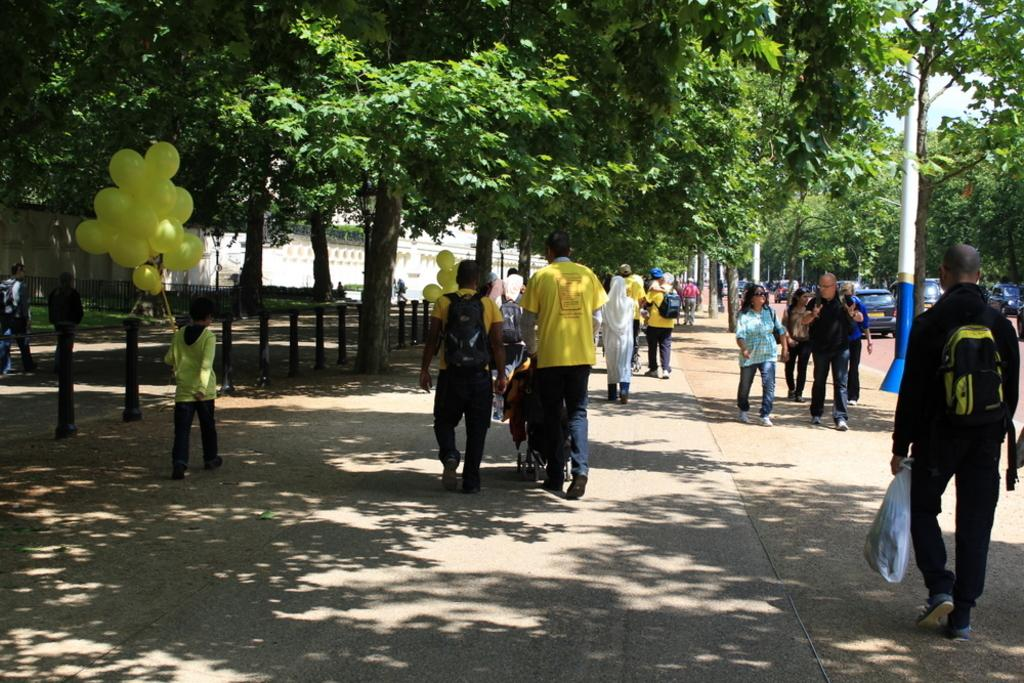What are the people in the image doing? The people in the image are walking. What objects are some people holding in the image? Some people are holding balloons and some are holding bags. What type of natural elements can be seen in the image? There are trees visible in the image. How many frogs can be seen sitting on the vase in the image? There are no frogs or vases present in the image. What type of bulb is used to light up the scene in the image? There is no mention of a bulb or lighting in the image; it is a daytime scene with natural light. 